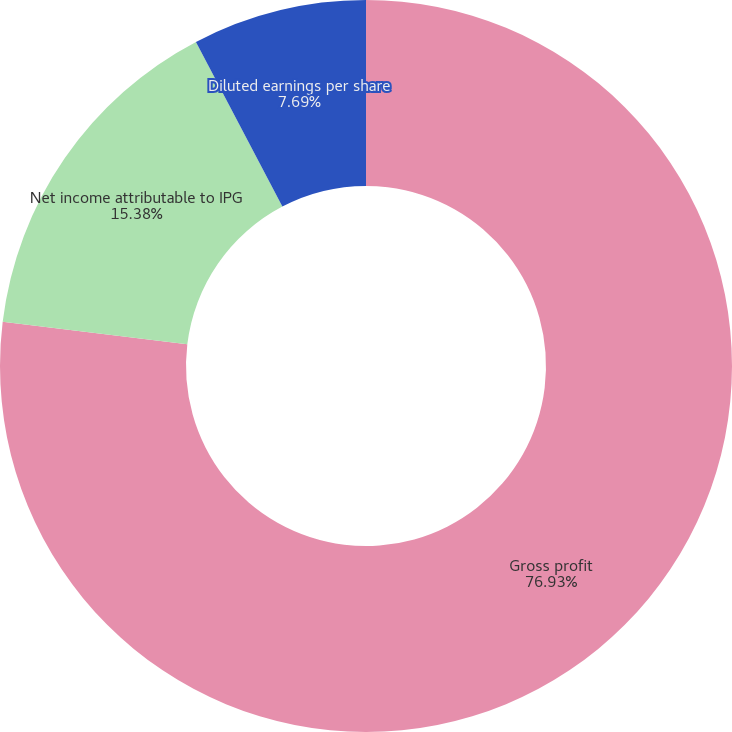Convert chart. <chart><loc_0><loc_0><loc_500><loc_500><pie_chart><fcel>Gross profit<fcel>Net income attributable to IPG<fcel>Basic earnings per share<fcel>Diluted earnings per share<nl><fcel>76.92%<fcel>15.38%<fcel>0.0%<fcel>7.69%<nl></chart> 